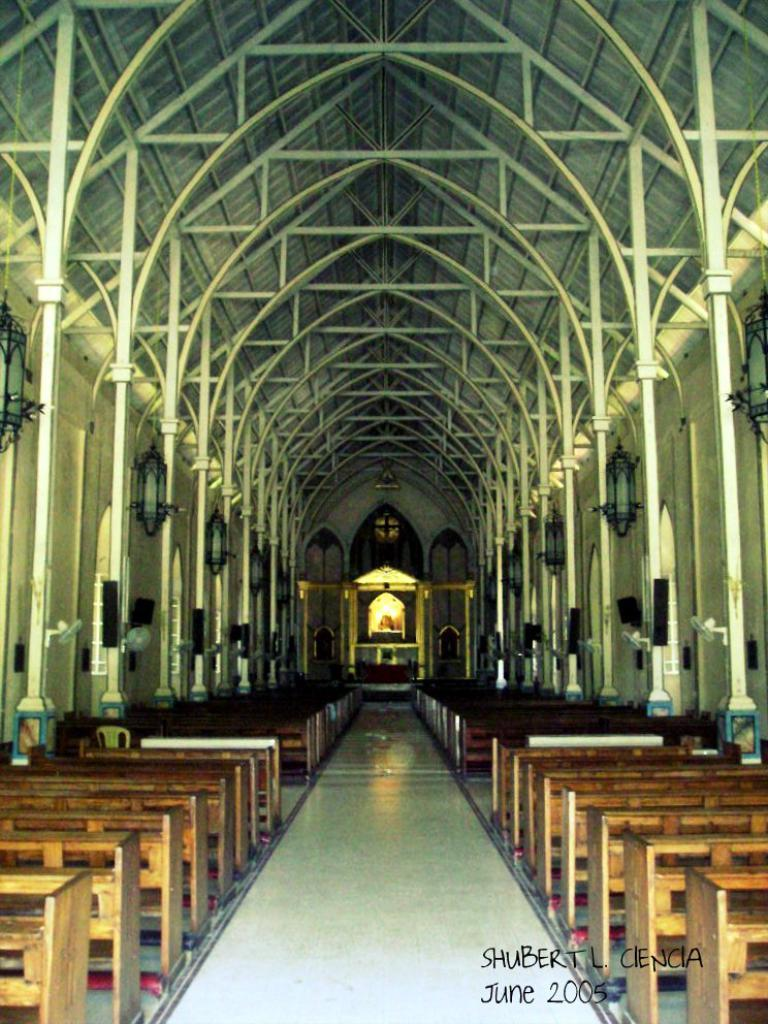Provide a one-sentence caption for the provided image. A narrow but very long church has many pews that sit below archways in June 2005. 